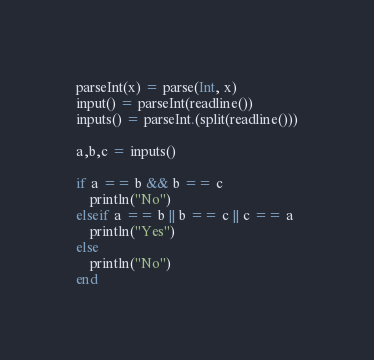Convert code to text. <code><loc_0><loc_0><loc_500><loc_500><_Julia_>parseInt(x) = parse(Int, x)
input() = parseInt(readline())
inputs() = parseInt.(split(readline()))

a,b,c = inputs()

if a == b && b == c
    println("No")
elseif a == b || b == c || c == a
    println("Yes")
else
    println("No")
end</code> 